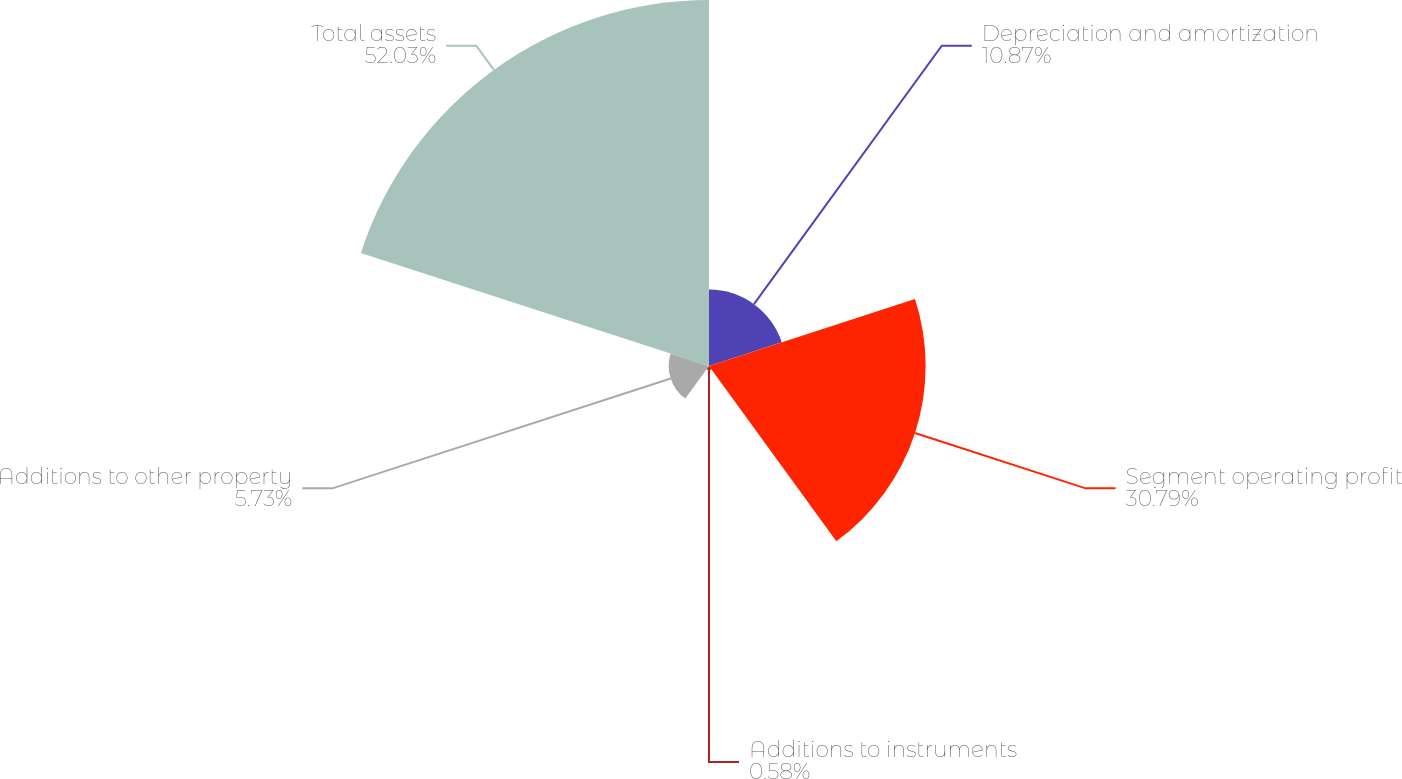<chart> <loc_0><loc_0><loc_500><loc_500><pie_chart><fcel>Depreciation and amortization<fcel>Segment operating profit<fcel>Additions to instruments<fcel>Additions to other property<fcel>Total assets<nl><fcel>10.87%<fcel>30.79%<fcel>0.58%<fcel>5.73%<fcel>52.02%<nl></chart> 